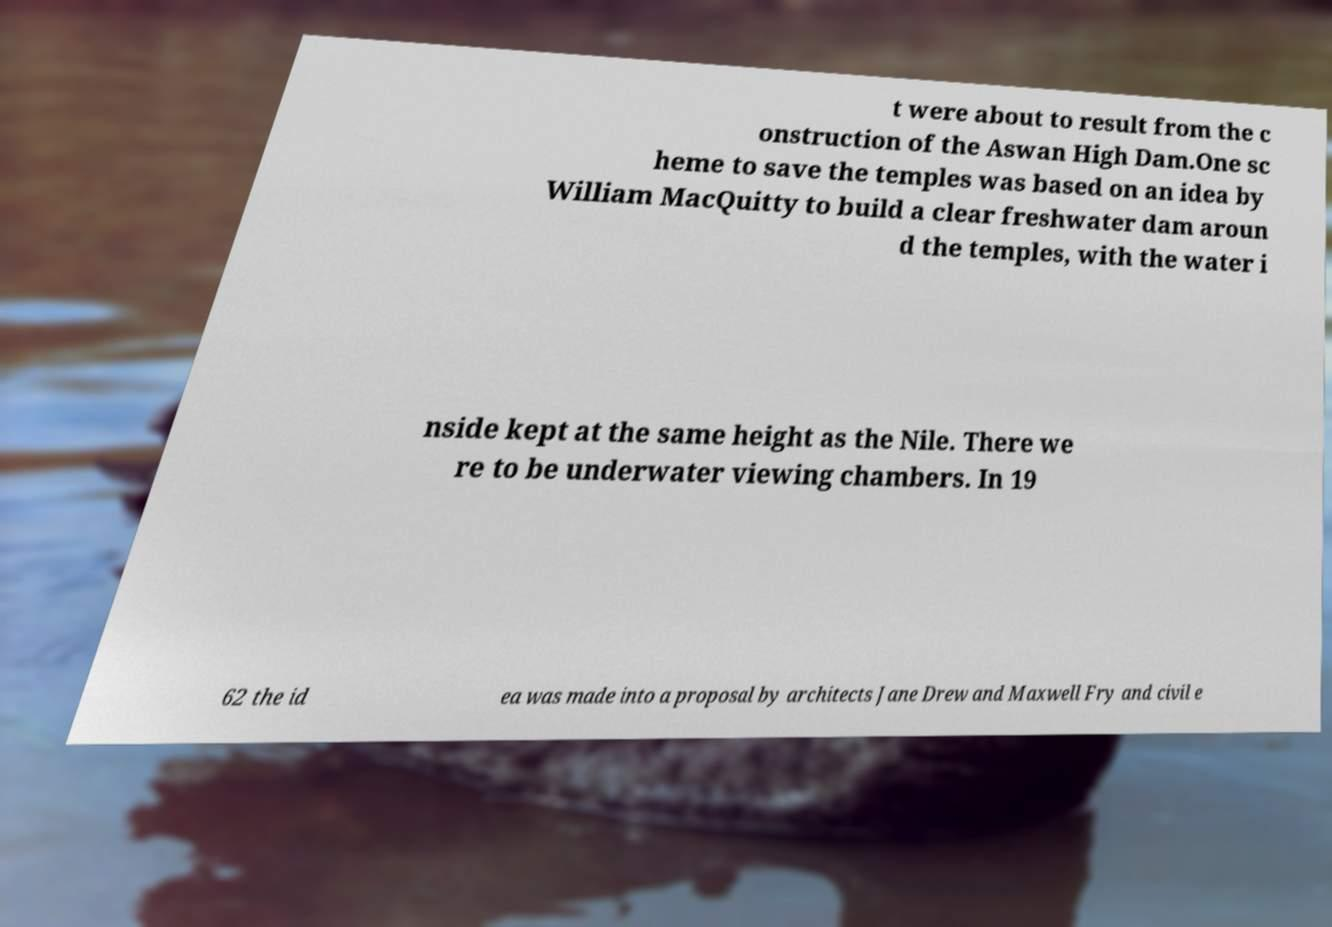Can you accurately transcribe the text from the provided image for me? t were about to result from the c onstruction of the Aswan High Dam.One sc heme to save the temples was based on an idea by William MacQuitty to build a clear freshwater dam aroun d the temples, with the water i nside kept at the same height as the Nile. There we re to be underwater viewing chambers. In 19 62 the id ea was made into a proposal by architects Jane Drew and Maxwell Fry and civil e 